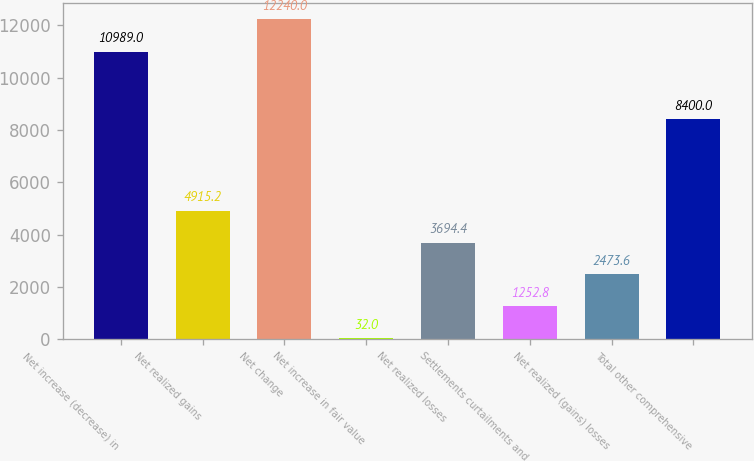Convert chart. <chart><loc_0><loc_0><loc_500><loc_500><bar_chart><fcel>Net increase (decrease) in<fcel>Net realized gains<fcel>Net change<fcel>Net increase in fair value<fcel>Net realized losses<fcel>Settlements curtailments and<fcel>Net realized (gains) losses<fcel>Total other comprehensive<nl><fcel>10989<fcel>4915.2<fcel>12240<fcel>32<fcel>3694.4<fcel>1252.8<fcel>2473.6<fcel>8400<nl></chart> 